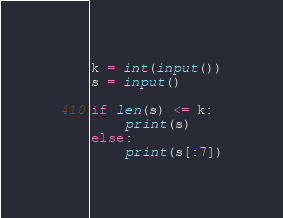<code> <loc_0><loc_0><loc_500><loc_500><_Python_>k = int(input())
s = input()

if len(s) <= k:
    print(s)
else:
    print(s[:7])</code> 